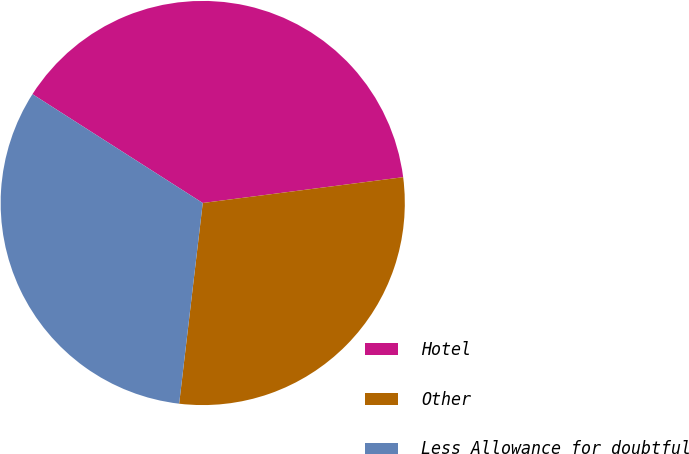<chart> <loc_0><loc_0><loc_500><loc_500><pie_chart><fcel>Hotel<fcel>Other<fcel>Less Allowance for doubtful<nl><fcel>38.91%<fcel>28.9%<fcel>32.19%<nl></chart> 